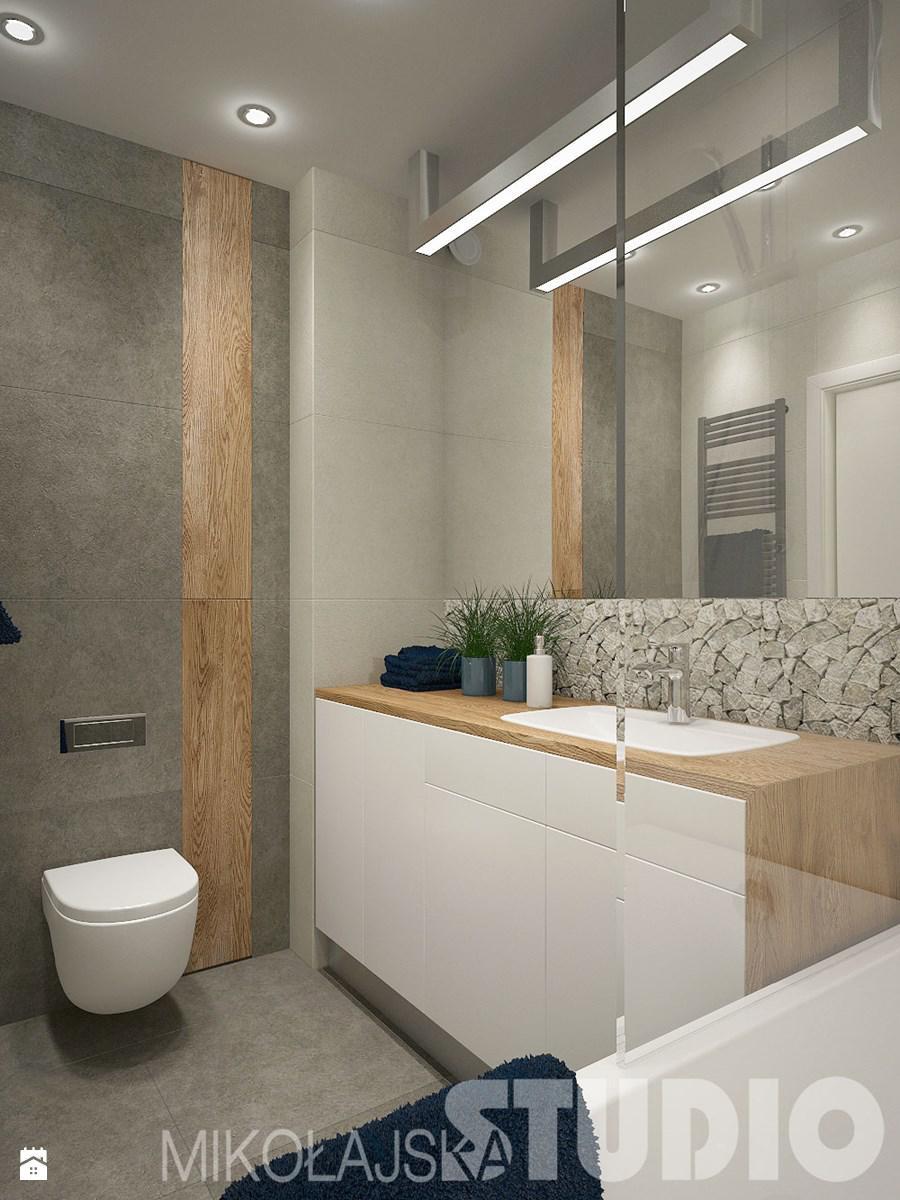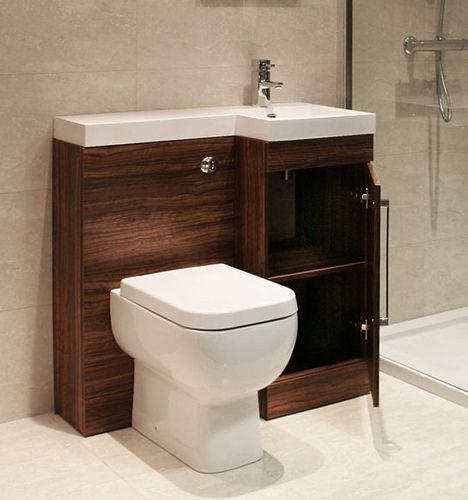The first image is the image on the left, the second image is the image on the right. Given the left and right images, does the statement "A commode is positioned in front of one side of a bathroom vanity, with a sink installed beside it in a wider area over a storage space." hold true? Answer yes or no. Yes. 